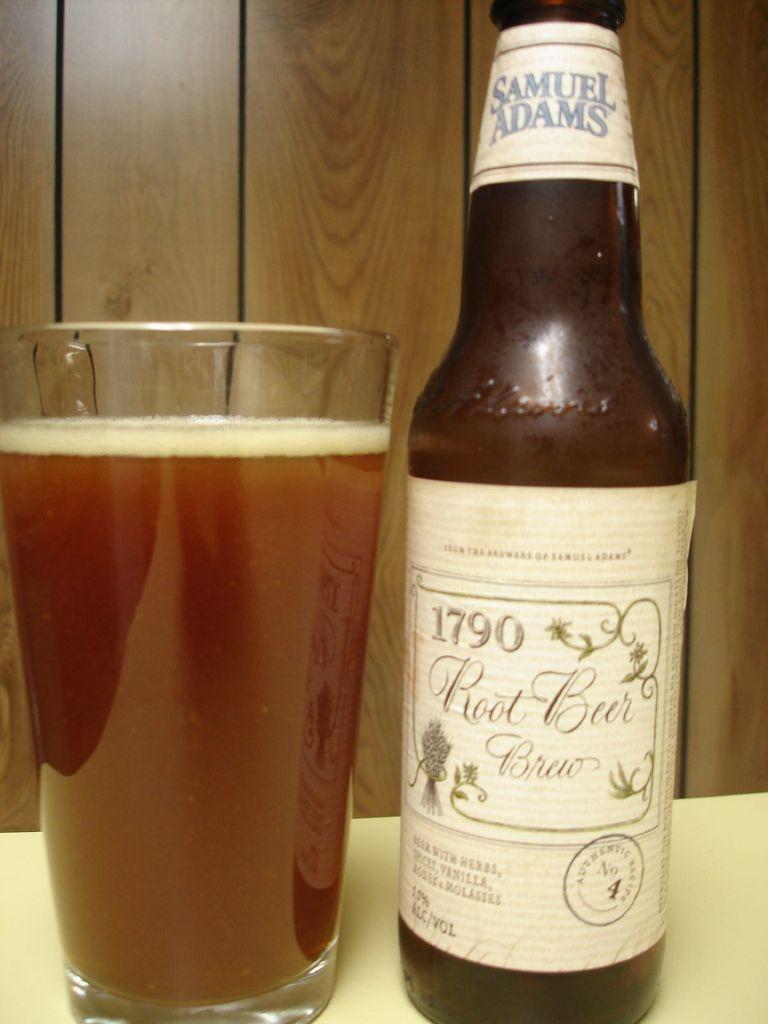Who makes that beer?
Offer a terse response. Samuel adams. What is the number on the beer bottle?
Ensure brevity in your answer.  1790. 